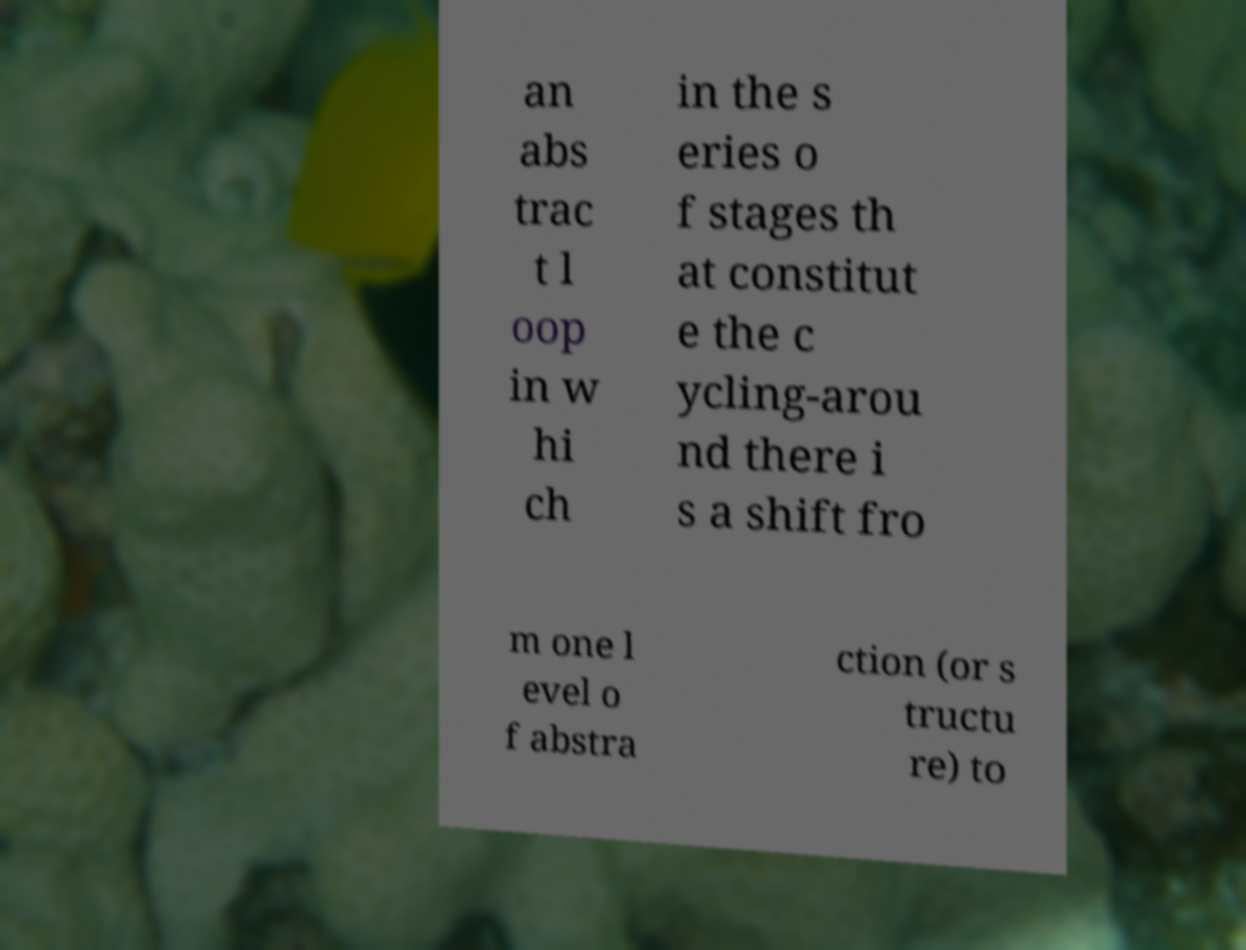For documentation purposes, I need the text within this image transcribed. Could you provide that? an abs trac t l oop in w hi ch in the s eries o f stages th at constitut e the c ycling-arou nd there i s a shift fro m one l evel o f abstra ction (or s tructu re) to 